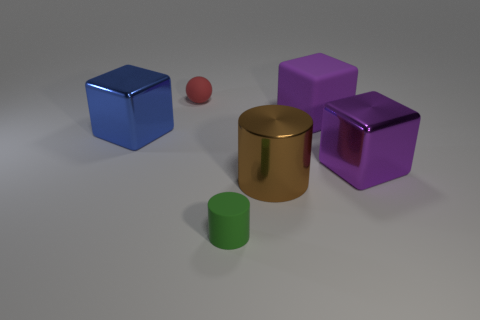There is a block behind the metallic block that is left of the big rubber cube; is there a small cylinder that is to the left of it?
Ensure brevity in your answer.  Yes. The cube that is the same color as the large rubber object is what size?
Ensure brevity in your answer.  Large. There is a purple rubber block; are there any red spheres behind it?
Provide a short and direct response. Yes. What number of other things are there of the same shape as the purple matte object?
Your response must be concise. 2. There is another object that is the same size as the red rubber object; what color is it?
Ensure brevity in your answer.  Green. Are there fewer tiny balls to the left of the red ball than metallic things on the right side of the green matte thing?
Your response must be concise. Yes. What number of large metallic blocks are to the right of the tiny rubber object left of the green matte thing that is in front of the brown metal thing?
Make the answer very short. 1. There is a purple metallic object that is the same shape as the big matte thing; what size is it?
Your answer should be compact. Large. Are there fewer spheres to the right of the tiny red rubber sphere than big red metal spheres?
Ensure brevity in your answer.  No. Is the large rubber object the same shape as the green thing?
Offer a very short reply. No. 